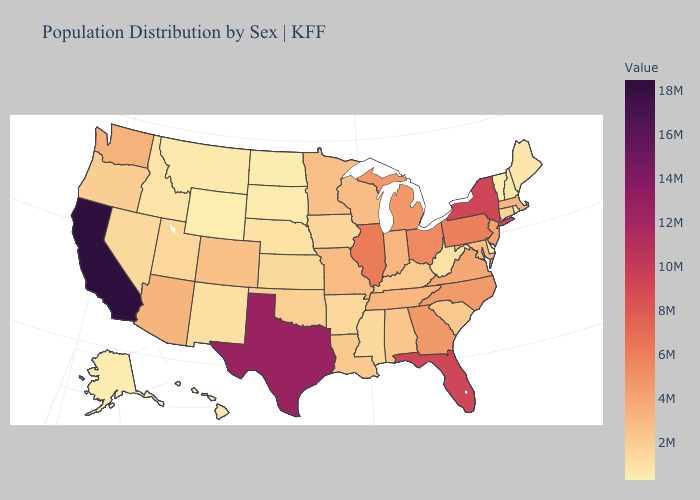Does Washington have the highest value in the West?
Keep it brief. No. Does Florida have a lower value than Texas?
Quick response, please. Yes. Which states have the highest value in the USA?
Write a very short answer. California. Which states hav the highest value in the West?
Keep it brief. California. Does California have the highest value in the USA?
Be succinct. Yes. Among the states that border Washington , does Oregon have the lowest value?
Short answer required. No. 